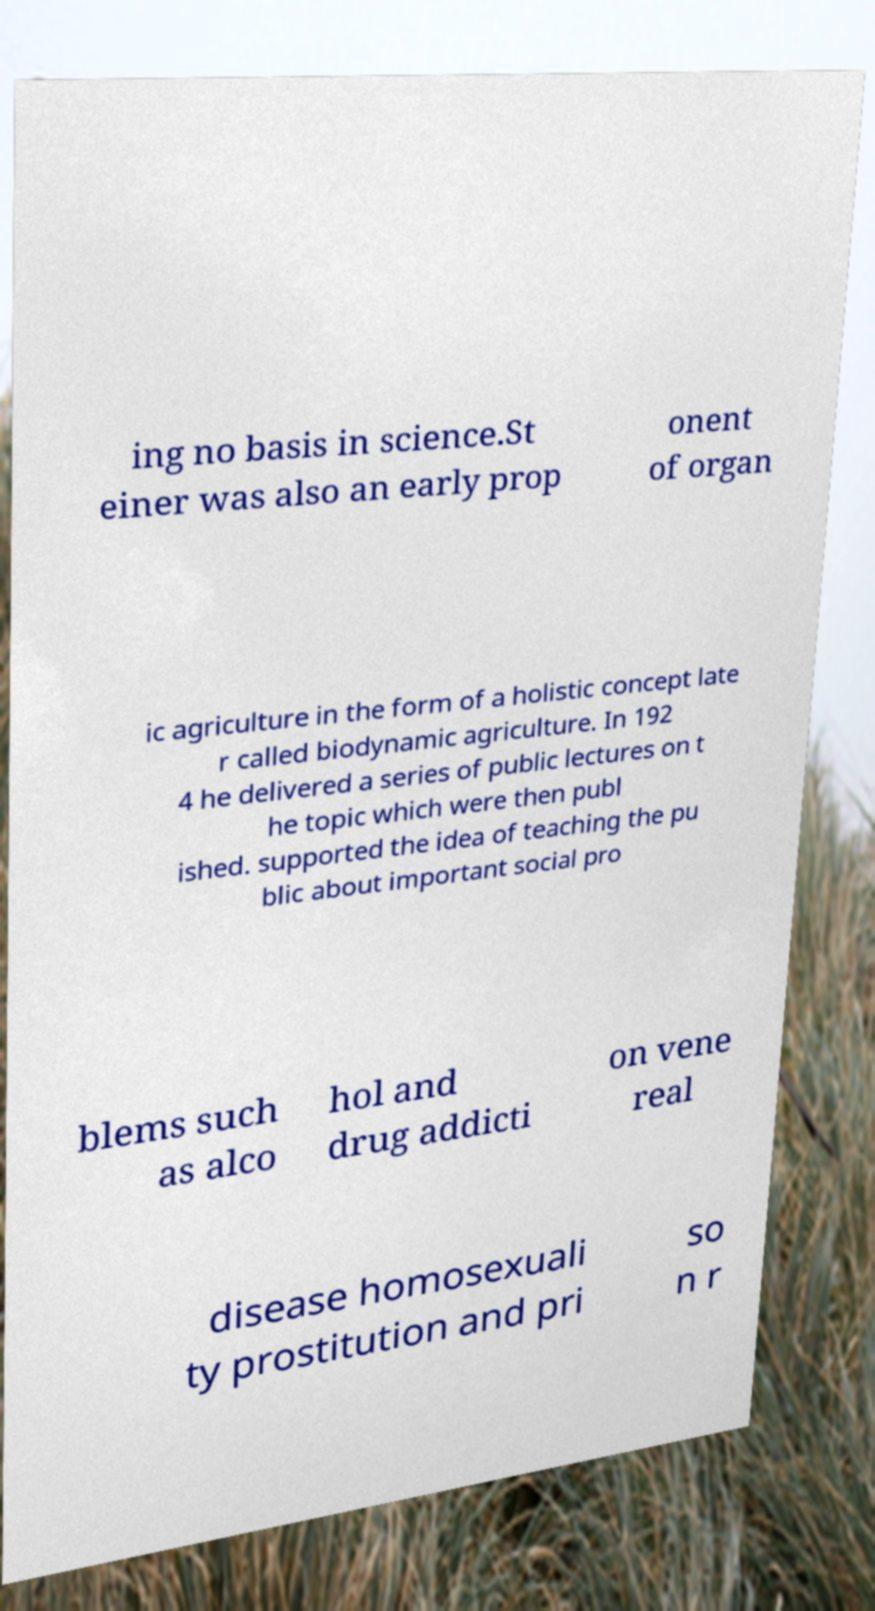Please read and relay the text visible in this image. What does it say? ing no basis in science.St einer was also an early prop onent of organ ic agriculture in the form of a holistic concept late r called biodynamic agriculture. In 192 4 he delivered a series of public lectures on t he topic which were then publ ished. supported the idea of teaching the pu blic about important social pro blems such as alco hol and drug addicti on vene real disease homosexuali ty prostitution and pri so n r 